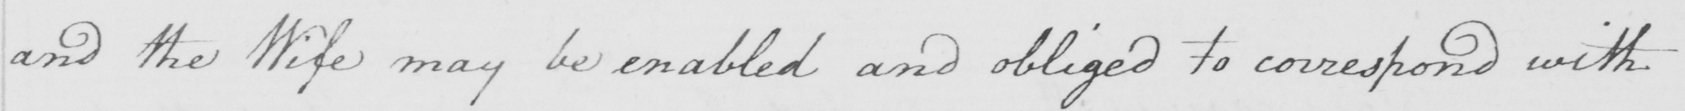Please transcribe the handwritten text in this image. and the Wife may be enabled and obliged to correspond with 